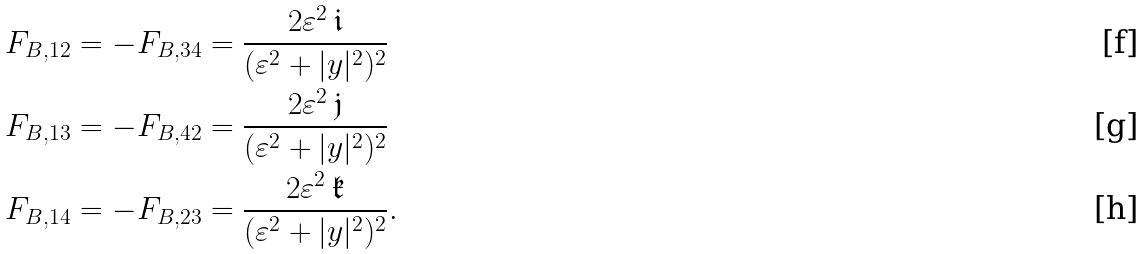Convert formula to latex. <formula><loc_0><loc_0><loc_500><loc_500>F _ { B , 1 2 } = - F _ { B , 3 4 } & = \frac { 2 \varepsilon ^ { 2 } \, \mathfrak { i } } { ( \varepsilon ^ { 2 } + | y | ^ { 2 } ) ^ { 2 } } \\ F _ { B , 1 3 } = - F _ { B , 4 2 } & = \frac { 2 \varepsilon ^ { 2 } \, \mathfrak { j } } { ( \varepsilon ^ { 2 } + | y | ^ { 2 } ) ^ { 2 } } \\ F _ { B , 1 4 } = - F _ { B , 2 3 } & = \frac { 2 \varepsilon ^ { 2 } \, \mathfrak { k } } { ( \varepsilon ^ { 2 } + | y | ^ { 2 } ) ^ { 2 } } .</formula> 